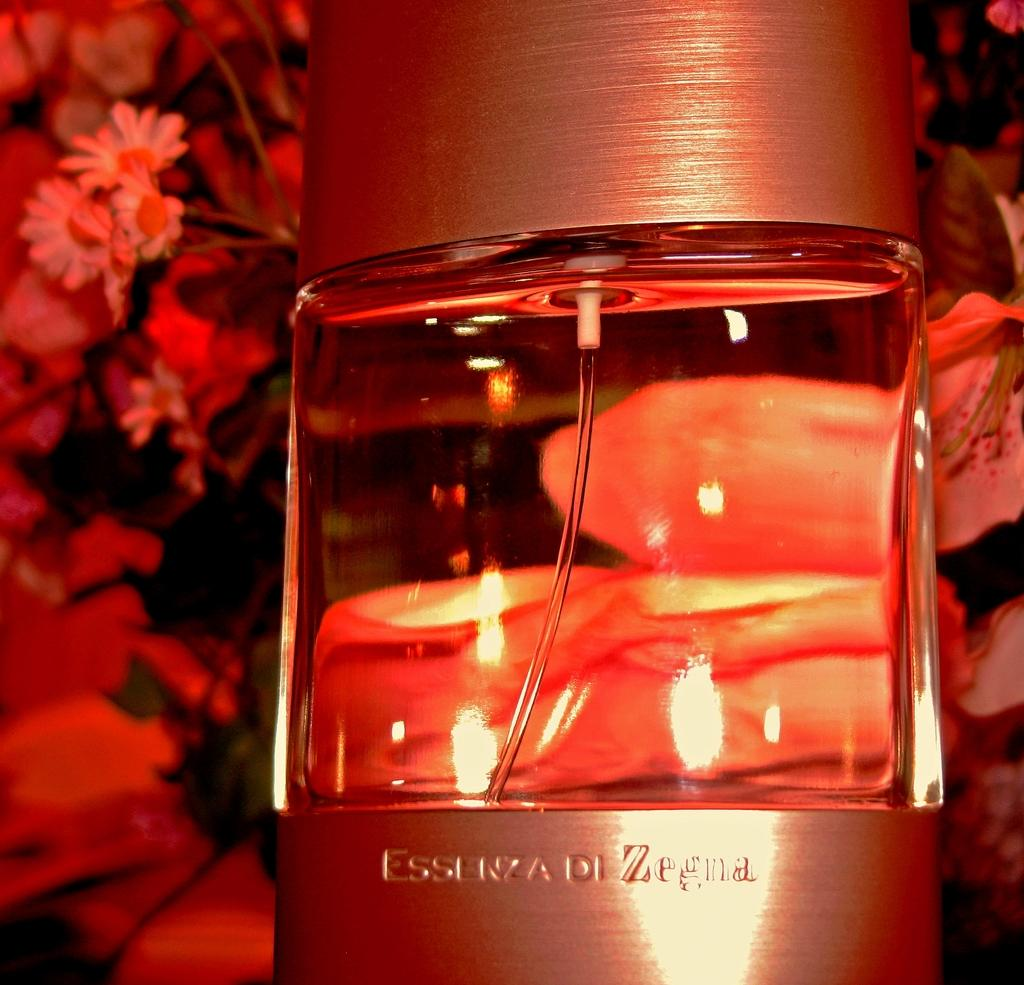What is in the glass that is visible in the image? There is a glass with water in it. What can be seen in the background of the image? There are flowers of different colors in the background. How does the skate contribute to the wealth of the person in the image? There is no skate or reference to wealth in the image; it only features a glass with water in it and flowers in the background. 